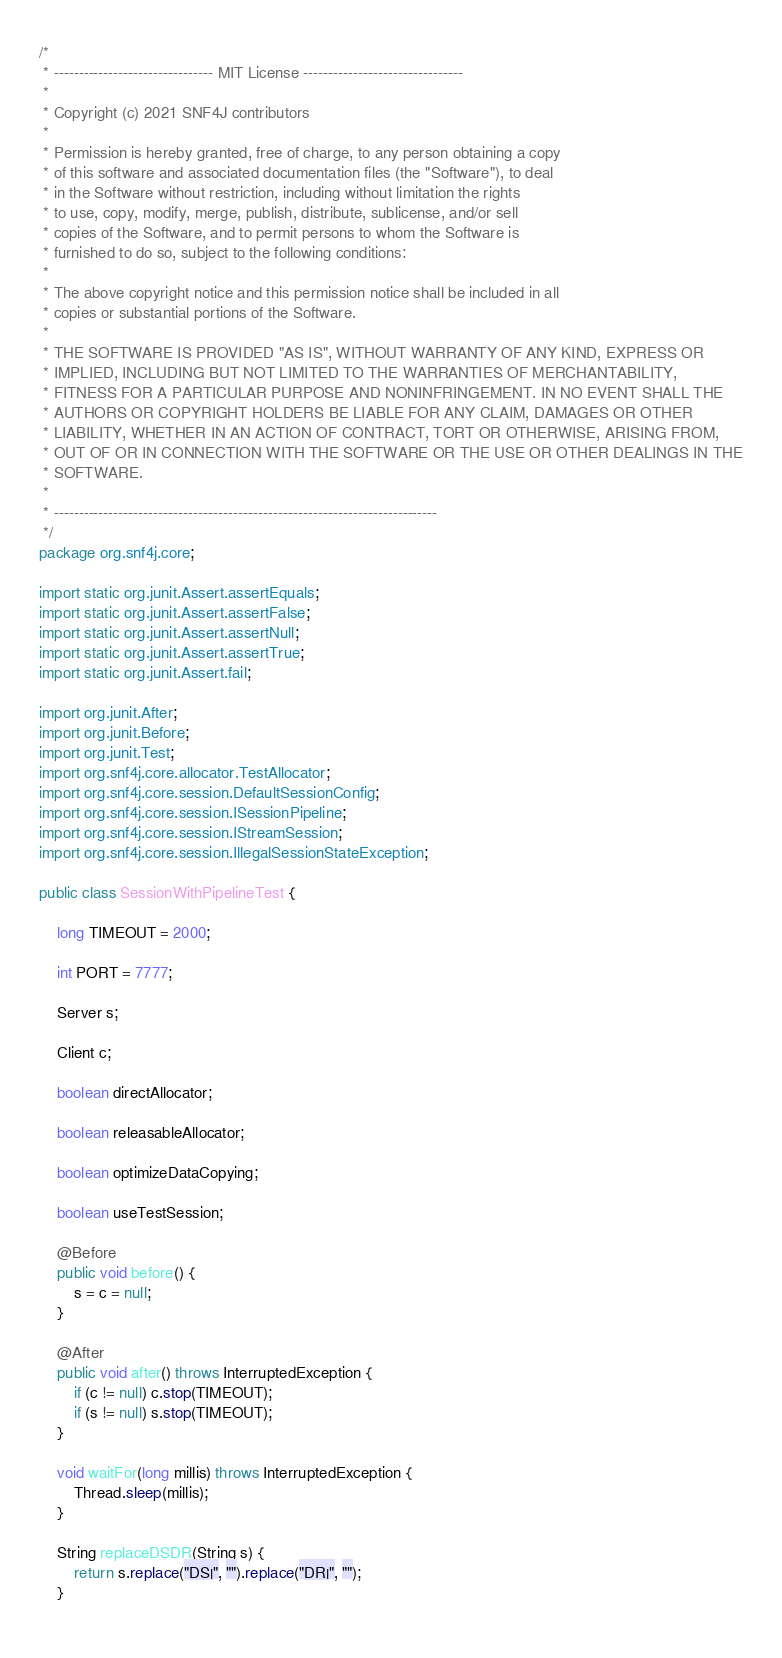Convert code to text. <code><loc_0><loc_0><loc_500><loc_500><_Java_>/*
 * -------------------------------- MIT License --------------------------------
 * 
 * Copyright (c) 2021 SNF4J contributors
 * 
 * Permission is hereby granted, free of charge, to any person obtaining a copy
 * of this software and associated documentation files (the "Software"), to deal
 * in the Software without restriction, including without limitation the rights
 * to use, copy, modify, merge, publish, distribute, sublicense, and/or sell
 * copies of the Software, and to permit persons to whom the Software is
 * furnished to do so, subject to the following conditions:
 * 
 * The above copyright notice and this permission notice shall be included in all
 * copies or substantial portions of the Software.
 * 
 * THE SOFTWARE IS PROVIDED "AS IS", WITHOUT WARRANTY OF ANY KIND, EXPRESS OR
 * IMPLIED, INCLUDING BUT NOT LIMITED TO THE WARRANTIES OF MERCHANTABILITY,
 * FITNESS FOR A PARTICULAR PURPOSE AND NONINFRINGEMENT. IN NO EVENT SHALL THE
 * AUTHORS OR COPYRIGHT HOLDERS BE LIABLE FOR ANY CLAIM, DAMAGES OR OTHER
 * LIABILITY, WHETHER IN AN ACTION OF CONTRACT, TORT OR OTHERWISE, ARISING FROM,
 * OUT OF OR IN CONNECTION WITH THE SOFTWARE OR THE USE OR OTHER DEALINGS IN THE
 * SOFTWARE.
 *
 * -----------------------------------------------------------------------------
 */
package org.snf4j.core;

import static org.junit.Assert.assertEquals;
import static org.junit.Assert.assertFalse;
import static org.junit.Assert.assertNull;
import static org.junit.Assert.assertTrue;
import static org.junit.Assert.fail;

import org.junit.After;
import org.junit.Before;
import org.junit.Test;
import org.snf4j.core.allocator.TestAllocator;
import org.snf4j.core.session.DefaultSessionConfig;
import org.snf4j.core.session.ISessionPipeline;
import org.snf4j.core.session.IStreamSession;
import org.snf4j.core.session.IllegalSessionStateException;

public class SessionWithPipelineTest {

	long TIMEOUT = 2000;
	
	int PORT = 7777;

	Server s;

	Client c;
	
	boolean directAllocator;
	
	boolean releasableAllocator;
	
	boolean optimizeDataCopying;
	
	boolean useTestSession;
	
	@Before
	public void before() {
		s = c = null;
	}
	
	@After
	public void after() throws InterruptedException {
		if (c != null) c.stop(TIMEOUT);
		if (s != null) s.stop(TIMEOUT);
	}
	
	void waitFor(long millis) throws InterruptedException {
		Thread.sleep(millis);
	}
	
	String replaceDSDR(String s) {
		return s.replace("DS|", "").replace("DR|", "");
	}
	</code> 